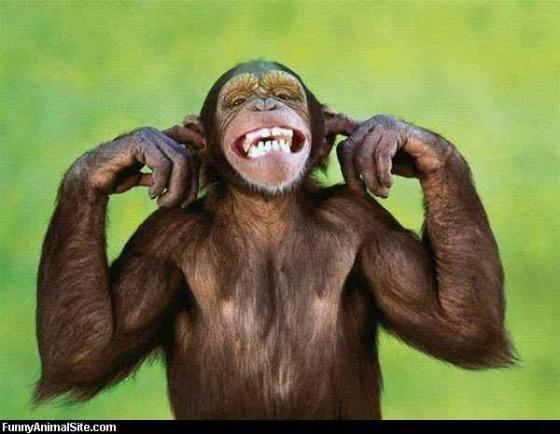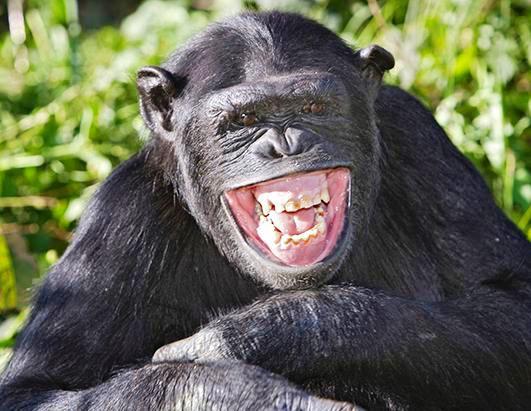The first image is the image on the left, the second image is the image on the right. For the images displayed, is the sentence "There are multiple chimps outside in the image on the right." factually correct? Answer yes or no. No. The first image is the image on the left, the second image is the image on the right. For the images displayed, is the sentence "An image contains one chimp, with arms folded across its chest and a wide, open grin on its face." factually correct? Answer yes or no. Yes. 